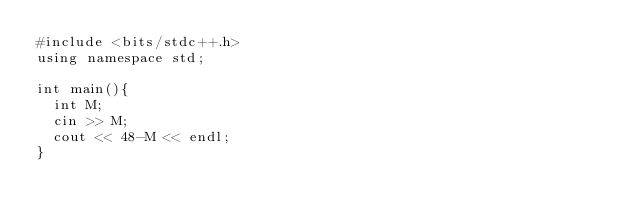<code> <loc_0><loc_0><loc_500><loc_500><_C++_>#include <bits/stdc++.h>
using namespace std;

int main(){
  int M;
  cin >> M;
  cout << 48-M << endl;
}</code> 